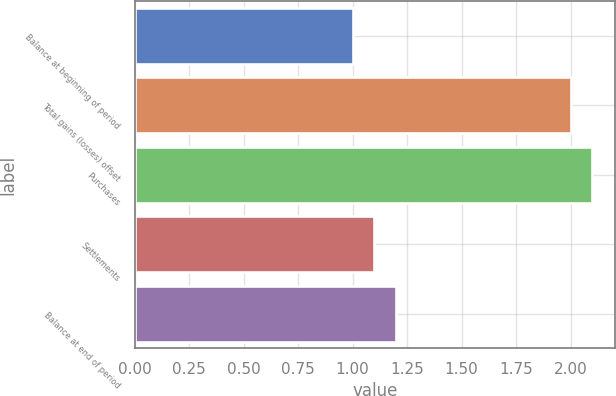Convert chart to OTSL. <chart><loc_0><loc_0><loc_500><loc_500><bar_chart><fcel>Balance at beginning of period<fcel>Total gains (losses) offset<fcel>Purchases<fcel>Settlements<fcel>Balance at end of period<nl><fcel>1<fcel>2<fcel>2.1<fcel>1.1<fcel>1.2<nl></chart> 